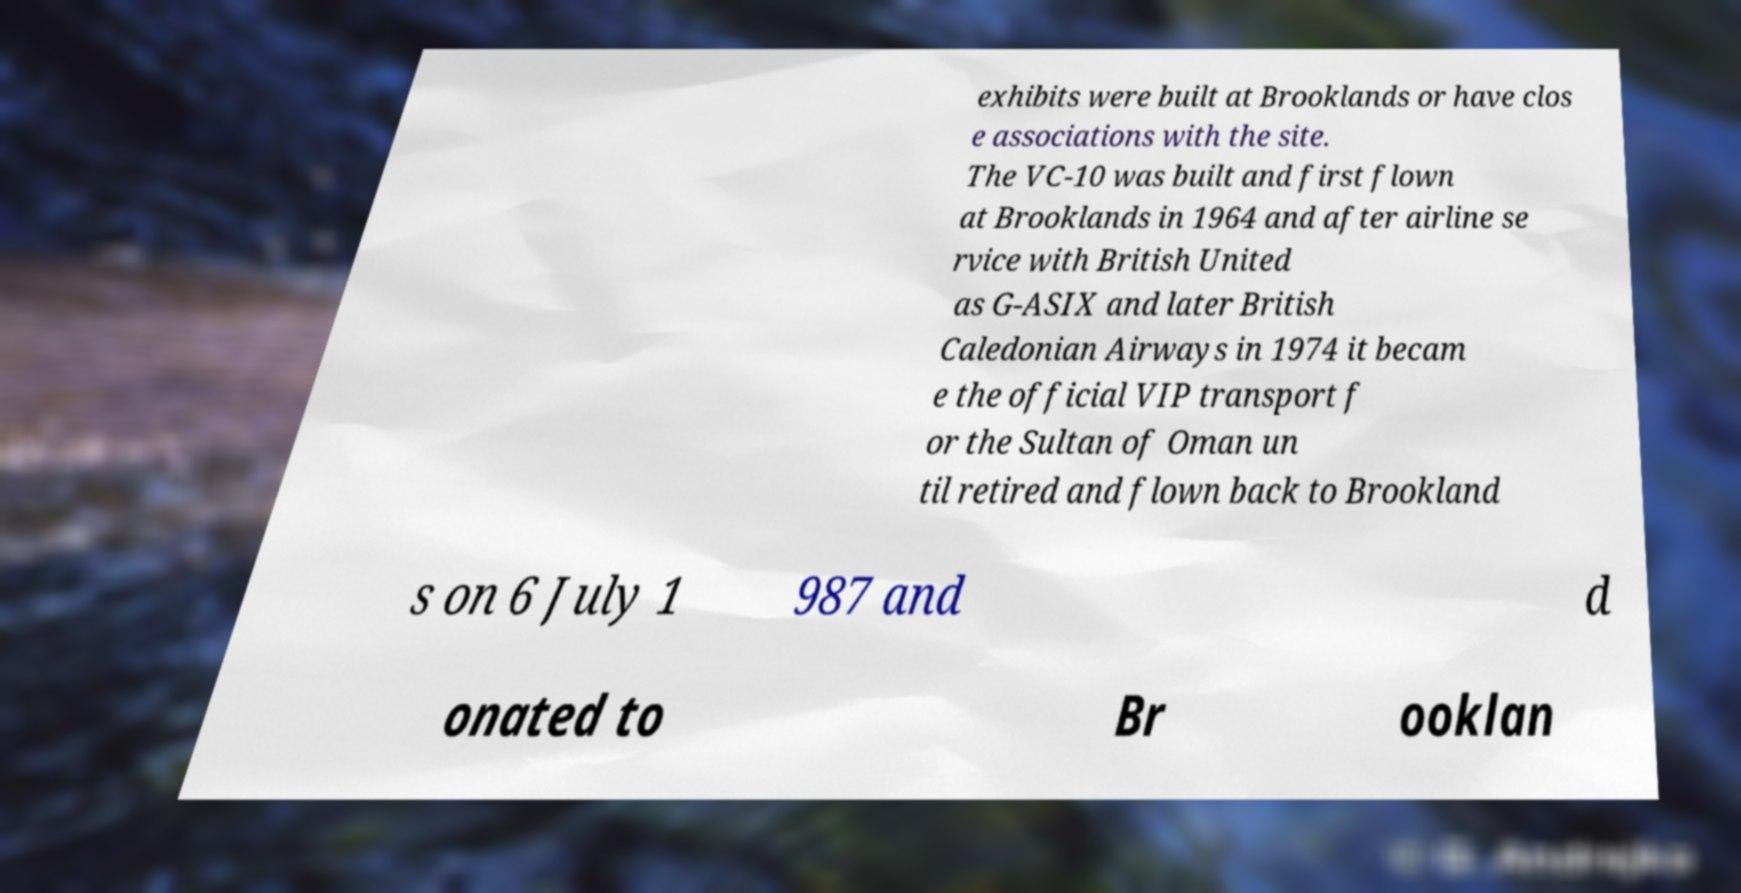Can you read and provide the text displayed in the image?This photo seems to have some interesting text. Can you extract and type it out for me? exhibits were built at Brooklands or have clos e associations with the site. The VC-10 was built and first flown at Brooklands in 1964 and after airline se rvice with British United as G-ASIX and later British Caledonian Airways in 1974 it becam e the official VIP transport f or the Sultan of Oman un til retired and flown back to Brookland s on 6 July 1 987 and d onated to Br ooklan 